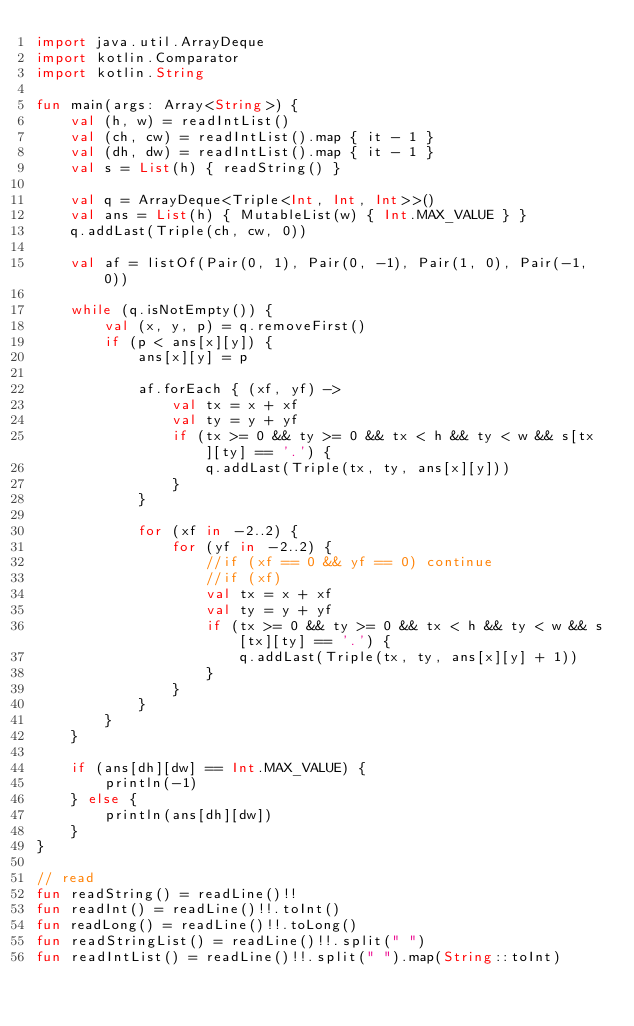Convert code to text. <code><loc_0><loc_0><loc_500><loc_500><_Kotlin_>import java.util.ArrayDeque
import kotlin.Comparator
import kotlin.String

fun main(args: Array<String>) {
    val (h, w) = readIntList()
    val (ch, cw) = readIntList().map { it - 1 }
    val (dh, dw) = readIntList().map { it - 1 }
    val s = List(h) { readString() }

    val q = ArrayDeque<Triple<Int, Int, Int>>()
    val ans = List(h) { MutableList(w) { Int.MAX_VALUE } }
    q.addLast(Triple(ch, cw, 0))

    val af = listOf(Pair(0, 1), Pair(0, -1), Pair(1, 0), Pair(-1, 0))

    while (q.isNotEmpty()) {
        val (x, y, p) = q.removeFirst()
        if (p < ans[x][y]) {
            ans[x][y] = p

            af.forEach { (xf, yf) ->
                val tx = x + xf
                val ty = y + yf
                if (tx >= 0 && ty >= 0 && tx < h && ty < w && s[tx][ty] == '.') {
                    q.addLast(Triple(tx, ty, ans[x][y]))
                }
            }

            for (xf in -2..2) {
                for (yf in -2..2) {
                    //if (xf == 0 && yf == 0) continue
                    //if (xf)
                    val tx = x + xf
                    val ty = y + yf
                    if (tx >= 0 && ty >= 0 && tx < h && ty < w && s[tx][ty] == '.') {
                        q.addLast(Triple(tx, ty, ans[x][y] + 1))
                    }
                }
            }
        }
    }

    if (ans[dh][dw] == Int.MAX_VALUE) {
        println(-1)
    } else {
        println(ans[dh][dw])
    }
}

// read
fun readString() = readLine()!!
fun readInt() = readLine()!!.toInt()
fun readLong() = readLine()!!.toLong()
fun readStringList() = readLine()!!.split(" ")
fun readIntList() = readLine()!!.split(" ").map(String::toInt)</code> 